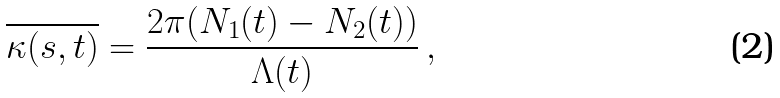<formula> <loc_0><loc_0><loc_500><loc_500>\overline { \kappa ( s , t ) } = \frac { 2 \pi ( N _ { 1 } ( t ) - N _ { 2 } ( t ) ) } { \Lambda ( t ) } \, ,</formula> 